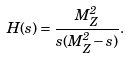Convert formula to latex. <formula><loc_0><loc_0><loc_500><loc_500>H ( s ) = \frac { M _ { Z } ^ { 2 } } { s ( M _ { Z } ^ { 2 } - s ) } .</formula> 